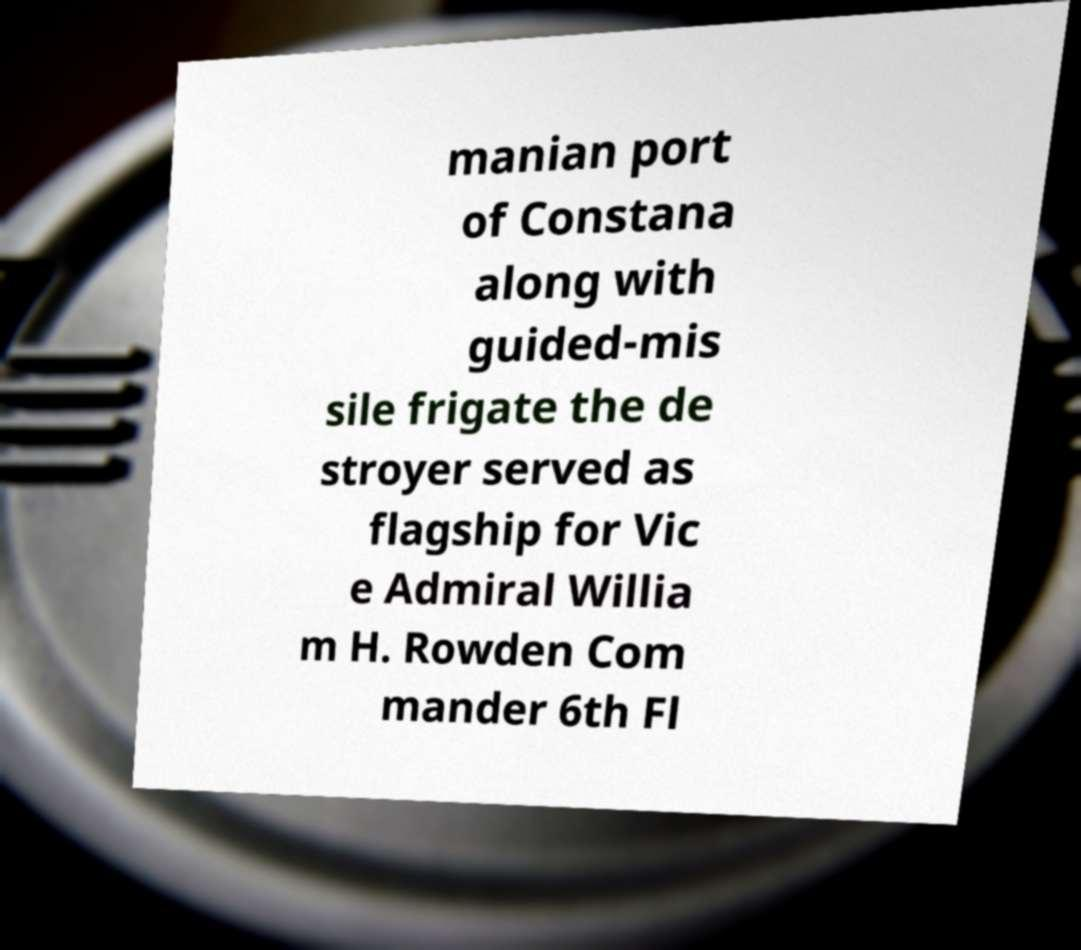Please identify and transcribe the text found in this image. manian port of Constana along with guided-mis sile frigate the de stroyer served as flagship for Vic e Admiral Willia m H. Rowden Com mander 6th Fl 